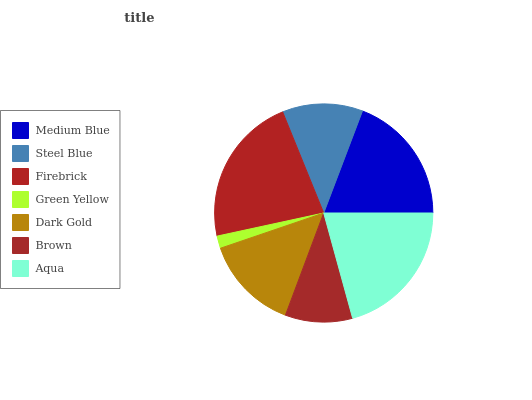Is Green Yellow the minimum?
Answer yes or no. Yes. Is Firebrick the maximum?
Answer yes or no. Yes. Is Steel Blue the minimum?
Answer yes or no. No. Is Steel Blue the maximum?
Answer yes or no. No. Is Medium Blue greater than Steel Blue?
Answer yes or no. Yes. Is Steel Blue less than Medium Blue?
Answer yes or no. Yes. Is Steel Blue greater than Medium Blue?
Answer yes or no. No. Is Medium Blue less than Steel Blue?
Answer yes or no. No. Is Dark Gold the high median?
Answer yes or no. Yes. Is Dark Gold the low median?
Answer yes or no. Yes. Is Steel Blue the high median?
Answer yes or no. No. Is Brown the low median?
Answer yes or no. No. 